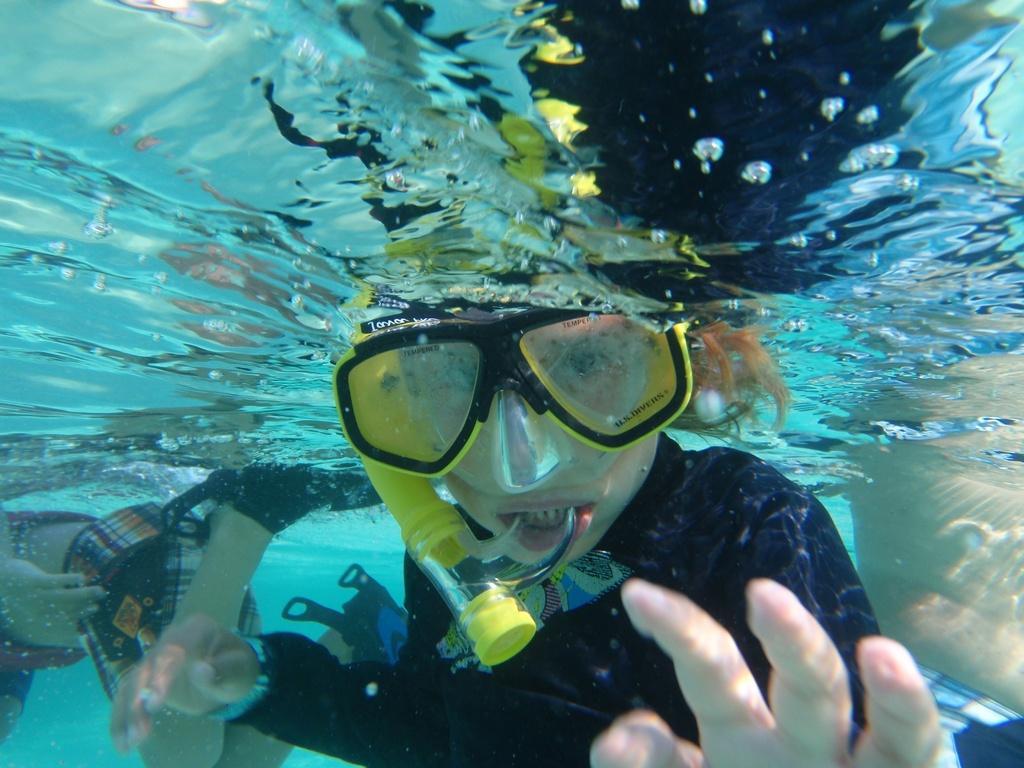Please provide a concise description of this image. Inside this water we can see people. This person wore goggles and kept pipe in his mouth.  